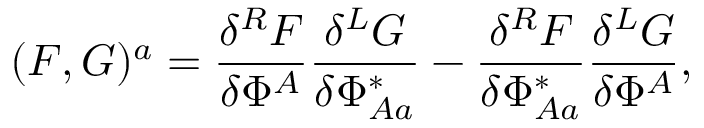Convert formula to latex. <formula><loc_0><loc_0><loc_500><loc_500>( F , G ) ^ { a } = \frac { \delta ^ { R } F } { \delta \Phi ^ { A } } \frac { \delta ^ { L } G } { \delta \Phi _ { A a } ^ { * } } - \frac { \delta ^ { R } F } { \delta \Phi _ { A a } ^ { * } } \frac { \delta ^ { L } G } { \delta \Phi ^ { A } } ,</formula> 